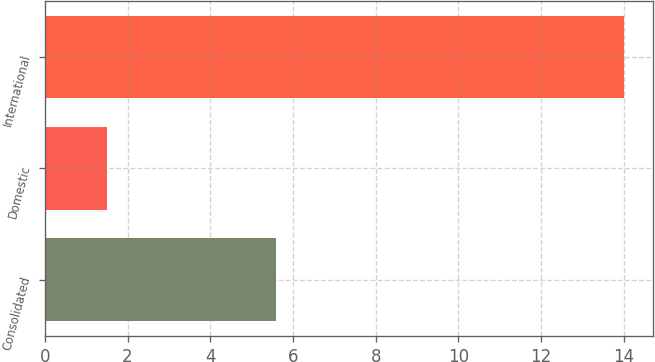<chart> <loc_0><loc_0><loc_500><loc_500><bar_chart><fcel>Consolidated<fcel>Domestic<fcel>International<nl><fcel>5.6<fcel>1.5<fcel>14<nl></chart> 